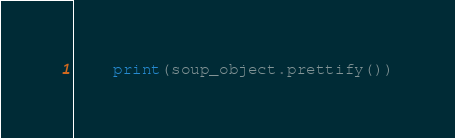Convert code to text. <code><loc_0><loc_0><loc_500><loc_500><_Python_>    print(soup_object.prettify())

</code> 